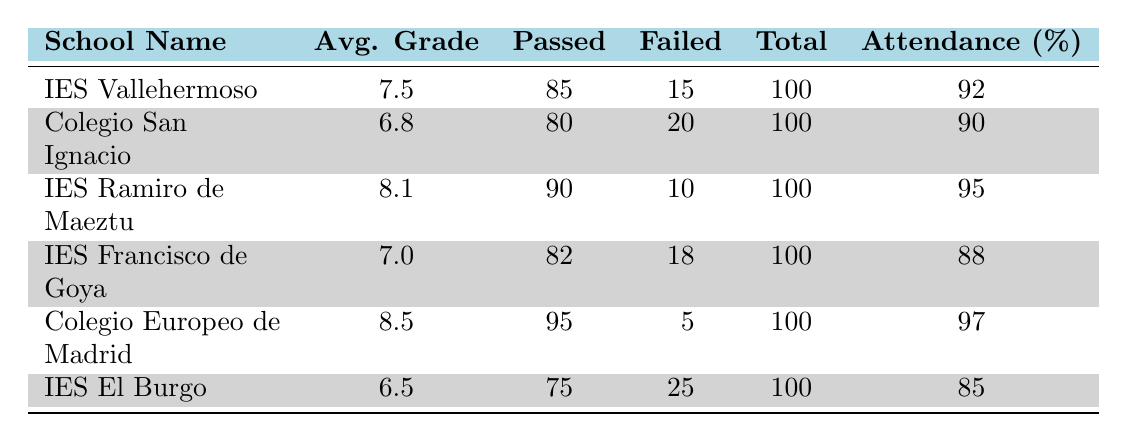What is the average grade of IES Vallehermoso? The table provides the average grade for each school. For IES Vallehermoso, it states 7.5.
Answer: 7.5 How many students passed at Colegio San Ignacio? According to the table, Colegio San Ignacio has 80 students who passed, as listed in the "Passed" column.
Answer: 80 Which school has the highest attendance rate? By comparing the "Attendance (%)" values for each school, Colegio Europeo de Madrid has the highest attendance rate of 97%.
Answer: 97 What is the total number of students who failed across all schools? To find the total number of students who failed, we add the "Failed" column: 15 + 20 + 10 + 18 + 5 + 25 = 93.
Answer: 93 Is the average grade of IES Ramiro de Maeztu higher than that of IES Francisco de Goya? IES Ramiro de Maeztu has an average grade of 8.1, while IES Francisco de Goya has 7.0. Thus, yes, IES Ramiro de Maeztu has a higher average grade.
Answer: Yes What is the average attendance rate of the schools listed? We sum the attendance rates (92 + 90 + 95 + 88 + 97 + 85 = 547) and divide by the total number of schools (6), yielding an average of 547/6 ≈ 91.17%.
Answer: 91.17 How many more students passed at Colegio Europeo de Madrid compared to IES El Burgo? Colegio Europeo de Madrid has 95 students who passed, while IES El Burgo has 75. The difference is 95 - 75 = 20.
Answer: 20 Does IES El Burgo have an attendance rate higher than 90%? IES El Burgo has an attendance rate of 85%, which is lower than 90%. Therefore, the answer is no.
Answer: No Which school has the lowest average grade? By examining the "Avg. Grade" values, IES El Burgo has the lowest average grade of 6.5.
Answer: 6.5 